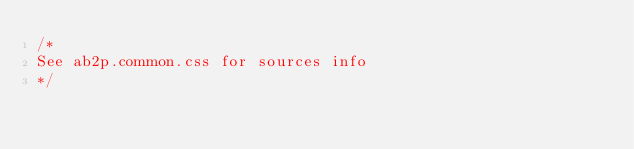<code> <loc_0><loc_0><loc_500><loc_500><_CSS_>/*
See ab2p.common.css for sources info
*/</code> 